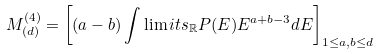Convert formula to latex. <formula><loc_0><loc_0><loc_500><loc_500>M _ { ( d ) } ^ { ( 4 ) } = \left [ ( a - b ) \int \lim i t s _ { \mathbb { R } } P ( E ) E ^ { a + b - 3 } d E \right ] _ { 1 \leq a , b \leq d }</formula> 